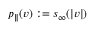Convert formula to latex. <formula><loc_0><loc_0><loc_500><loc_500>p _ { \| } ( v ) \colon = s _ { \infty } ( | v | )</formula> 